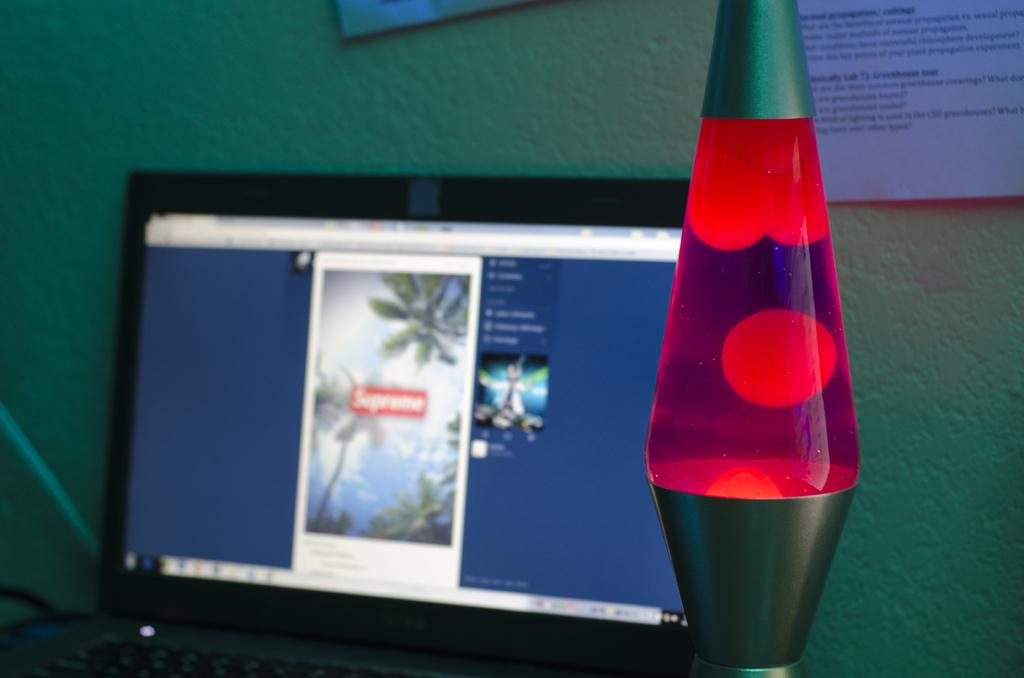<image>
Create a compact narrative representing the image presented. A laptop in the background with a image saying supreme 